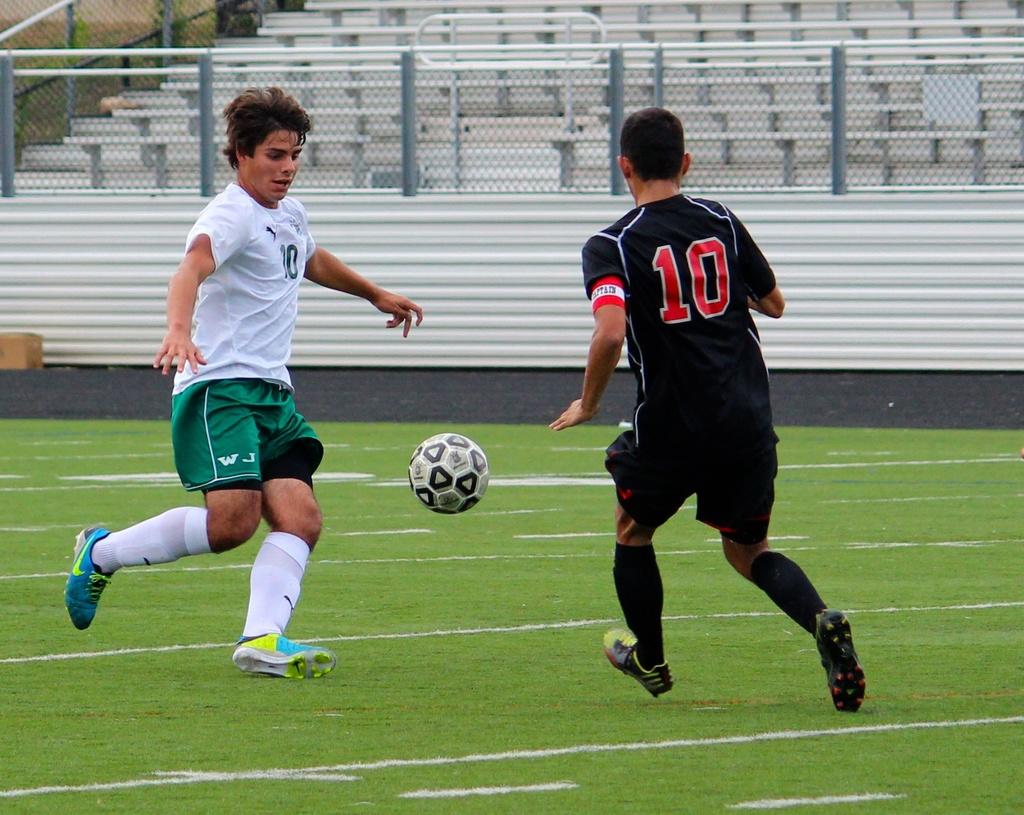What initials are on the green shorts?
Your answer should be very brief. Wj. 